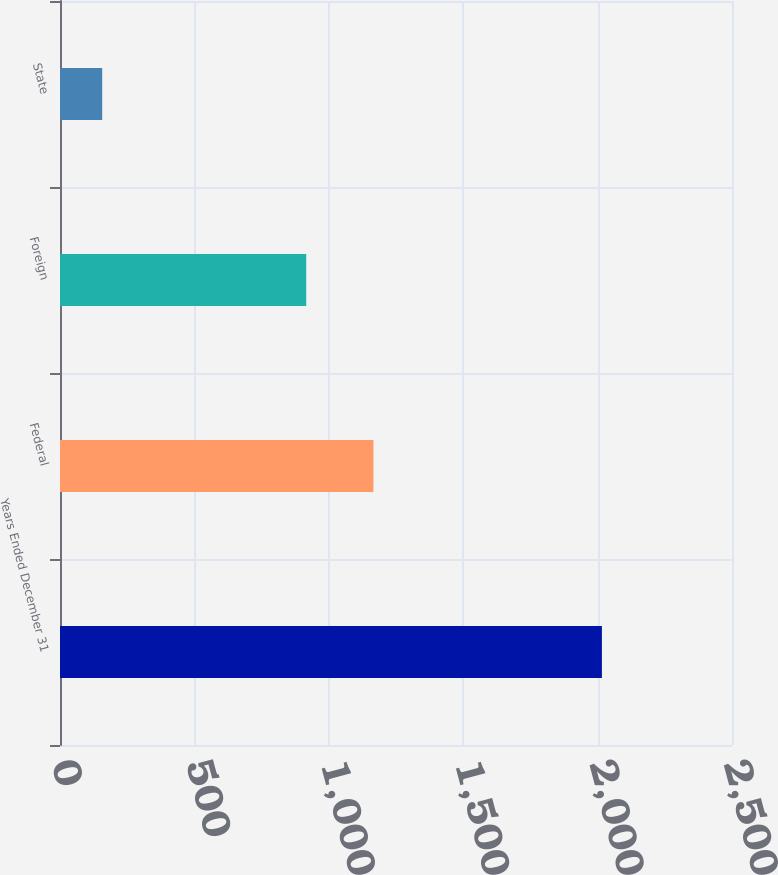Convert chart to OTSL. <chart><loc_0><loc_0><loc_500><loc_500><bar_chart><fcel>Years Ended December 31<fcel>Federal<fcel>Foreign<fcel>State<nl><fcel>2016<fcel>1166<fcel>916<fcel>157<nl></chart> 